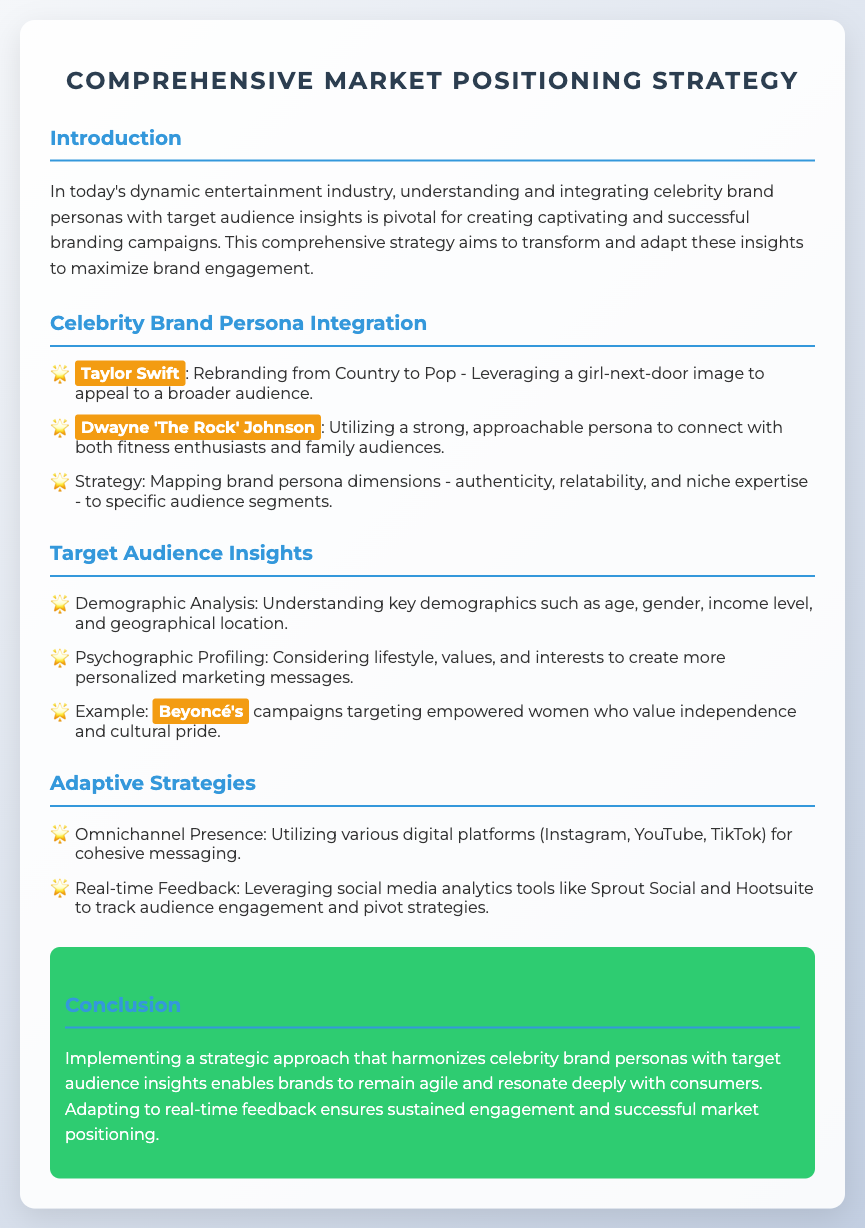What is the title of the document? The title is mentioned at the top of the document in the header section.
Answer: Comprehensive Market Positioning Strategy Who is mentioned as a celebrity with a strong, approachable persona? The document lists specific celebrities alongside descriptions of their brand personas.
Answer: Dwayne 'The Rock' Johnson What type of analysis is used to understand key demographics? The document outlines various analysis methods used for understanding audiences.
Answer: Demographic Analysis Who is mentioned as targeting empowered women? The document provides examples of celebrities and their target audiences.
Answer: Beyoncé What platforms are suggested for an omnichannel presence? The document lists specific platforms that can be utilized for messaging.
Answer: Instagram, YouTube, TikTok What is the highlight color used in the document? The color for highlighting key terms is consistently used throughout the text.
Answer: Orange What is the main objective of the comprehensive strategy? The document indicates the primary aim of integrating insights into brand campaigns.
Answer: Maximize brand engagement What type of feedback is leveraged for adaptive strategies? The document discusses how brands can modify their strategies based on audience interactions.
Answer: Real-time Feedback 